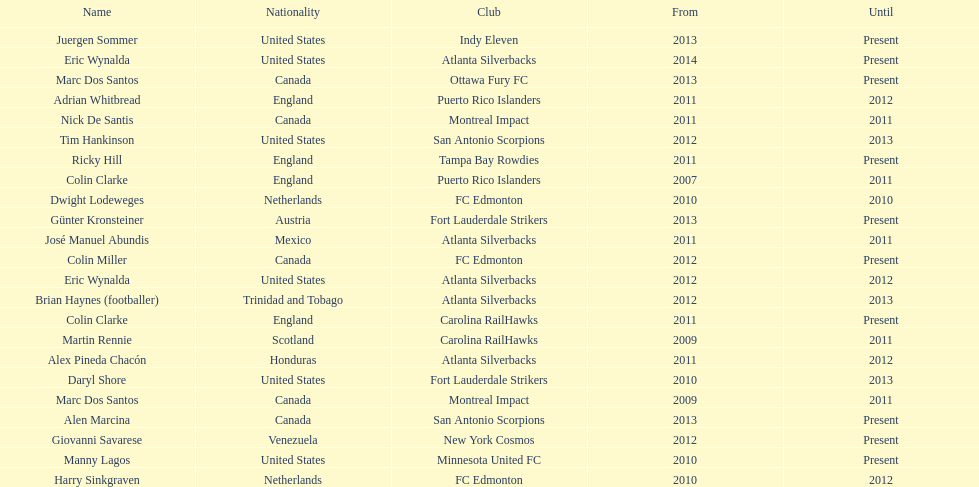How long did colin clarke coach the puerto rico islanders? 4 years. 